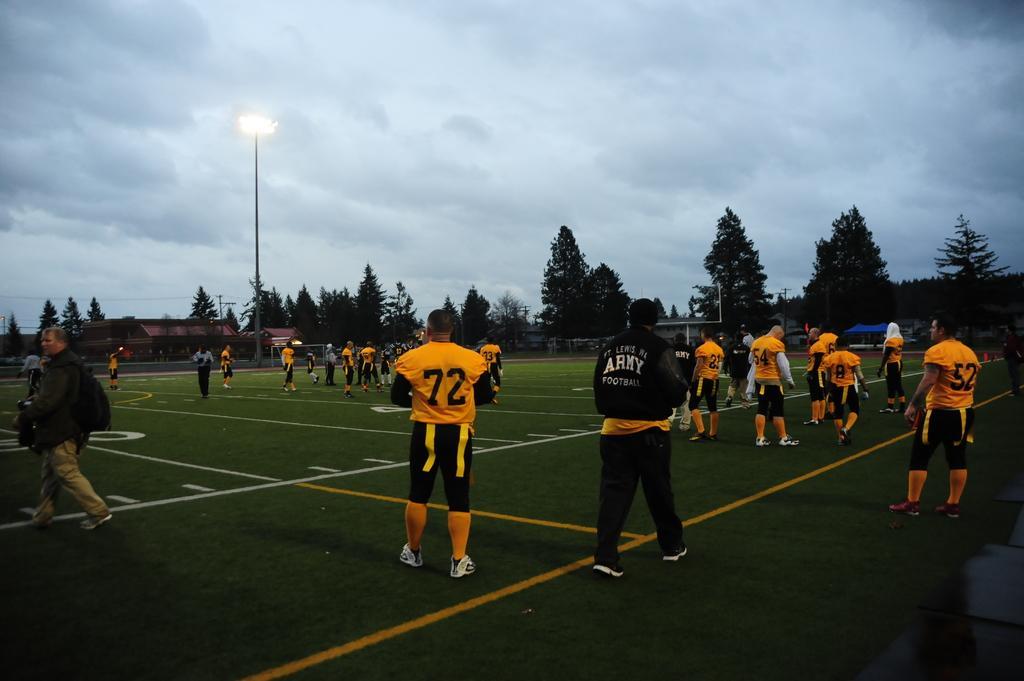Can you describe this image briefly? In the front of the image there are people, ground, building, light pole, trees and objects. In the background of the image there is a cloudy sky. Among them few people are walking and holding objects. 